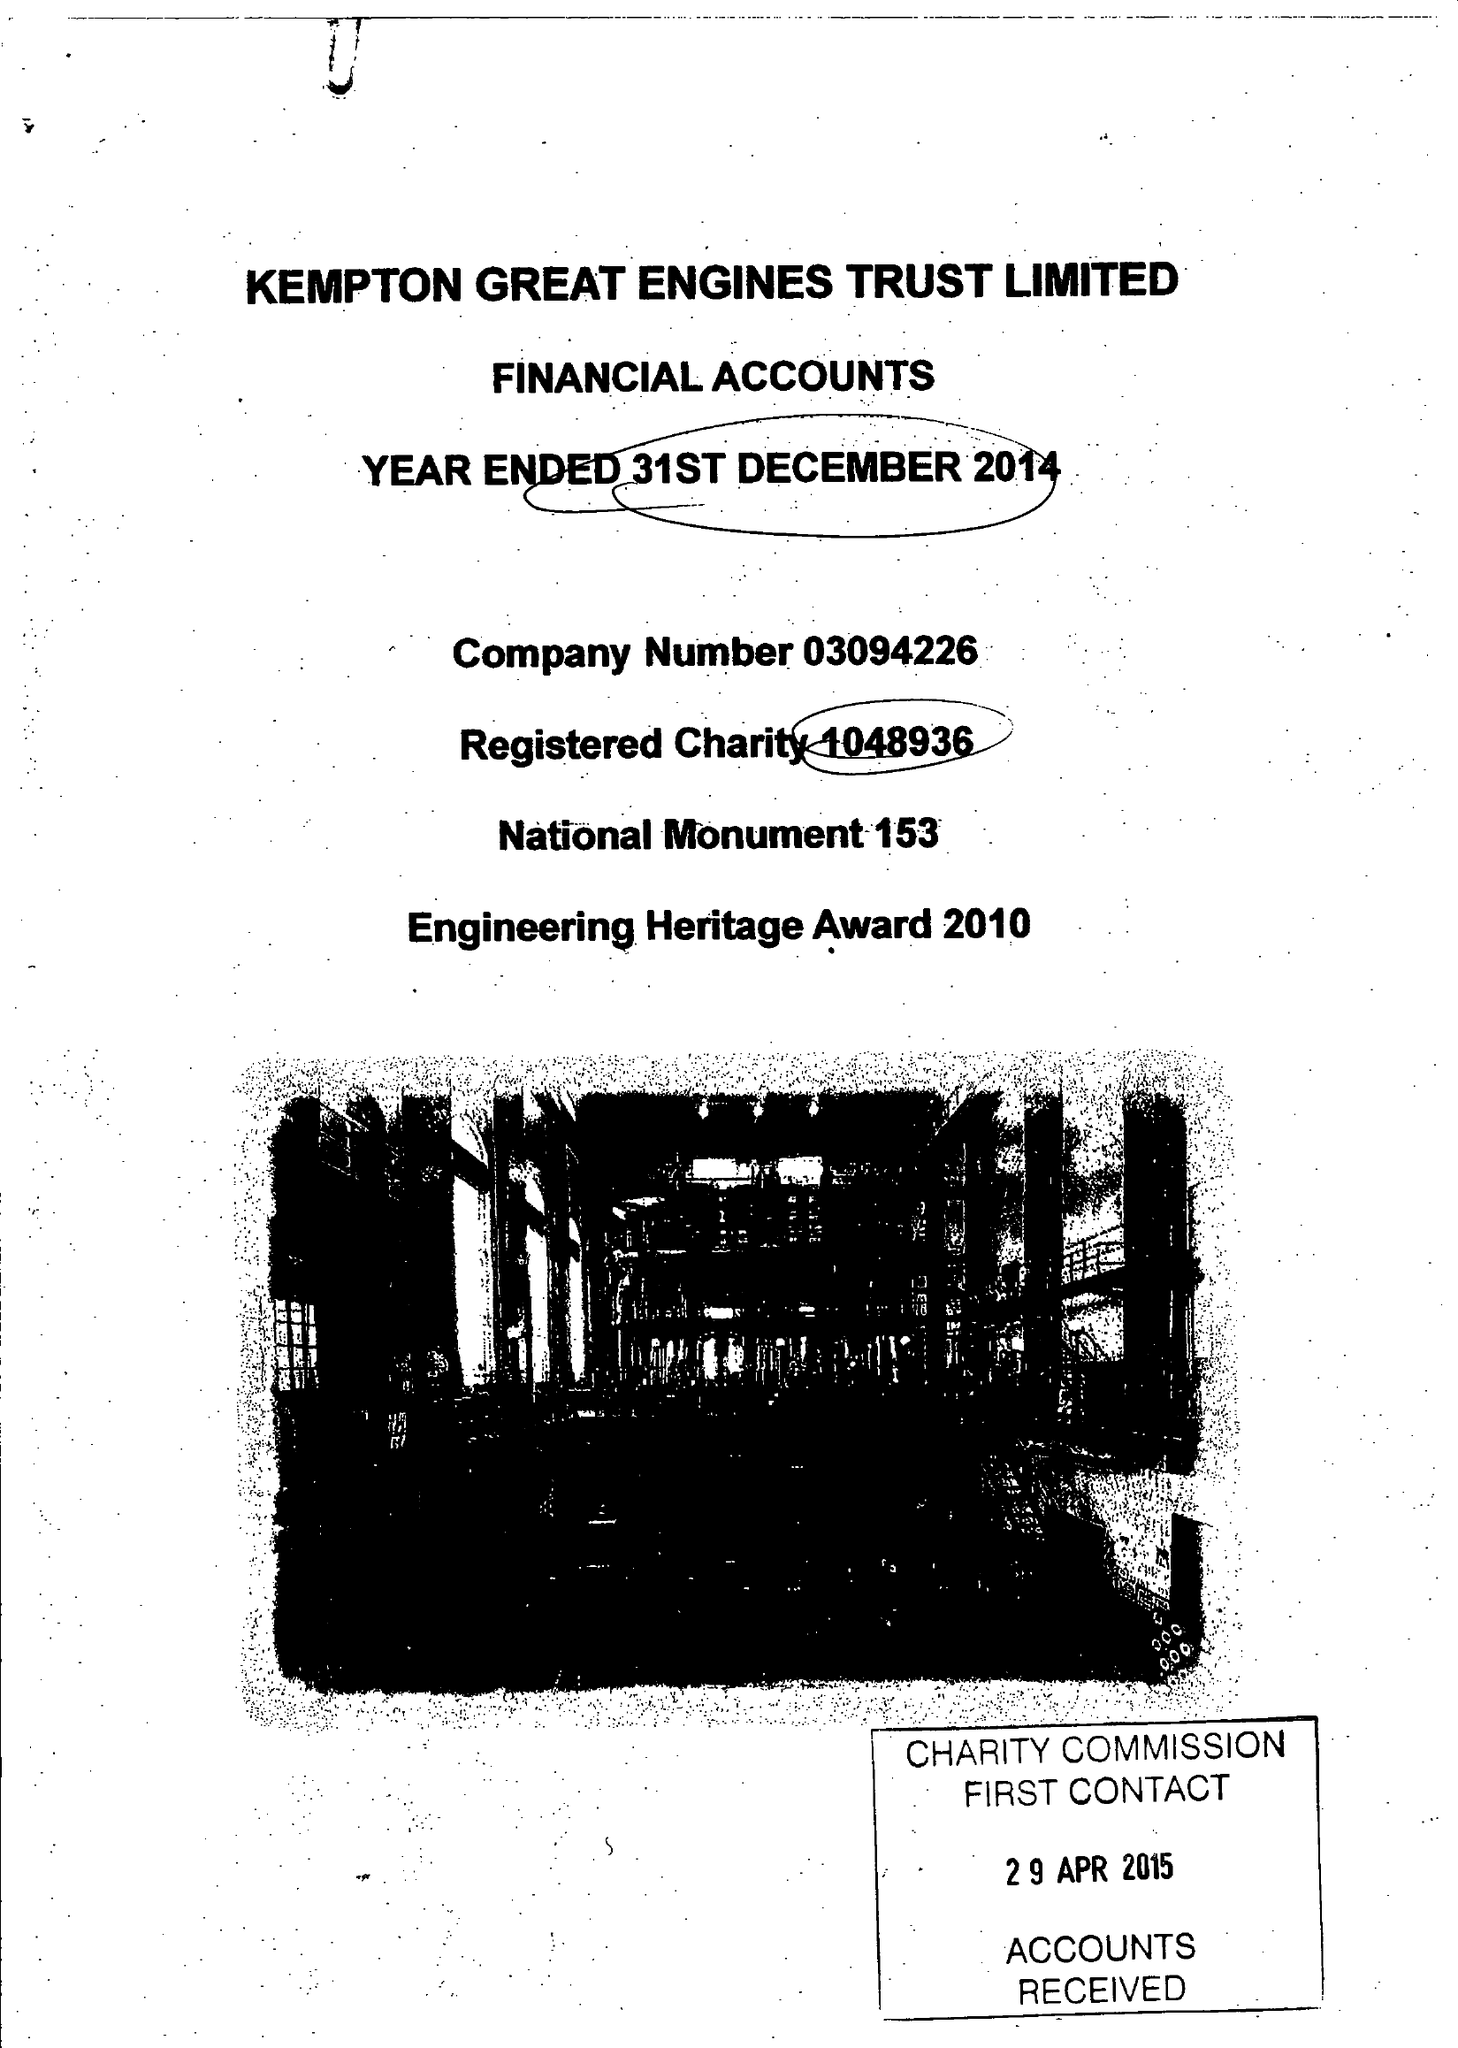What is the value for the income_annually_in_british_pounds?
Answer the question using a single word or phrase. 34666.00 